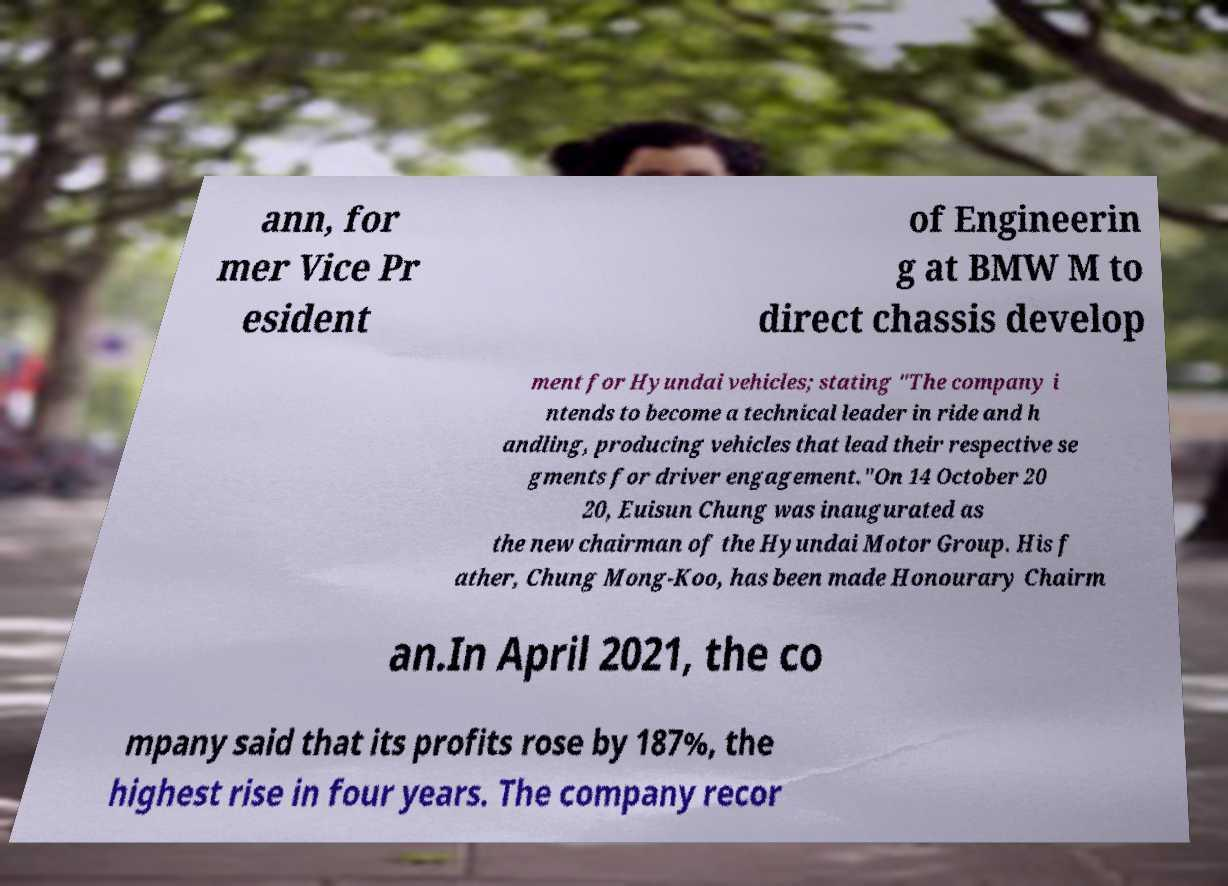I need the written content from this picture converted into text. Can you do that? ann, for mer Vice Pr esident of Engineerin g at BMW M to direct chassis develop ment for Hyundai vehicles; stating "The company i ntends to become a technical leader in ride and h andling, producing vehicles that lead their respective se gments for driver engagement."On 14 October 20 20, Euisun Chung was inaugurated as the new chairman of the Hyundai Motor Group. His f ather, Chung Mong-Koo, has been made Honourary Chairm an.In April 2021, the co mpany said that its profits rose by 187%, the highest rise in four years. The company recor 